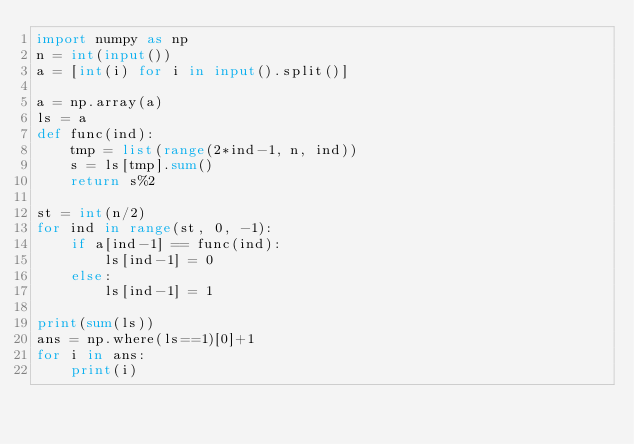<code> <loc_0><loc_0><loc_500><loc_500><_Python_>import numpy as np
n = int(input())
a = [int(i) for i in input().split()] 

a = np.array(a)
ls = a
def func(ind):
    tmp = list(range(2*ind-1, n, ind))
    s = ls[tmp].sum()
    return s%2

st = int(n/2)
for ind in range(st, 0, -1):
    if a[ind-1] == func(ind):
        ls[ind-1] = 0
    else:
        ls[ind-1] = 1
        
print(sum(ls))
ans = np.where(ls==1)[0]+1
for i in ans:
    print(i)</code> 